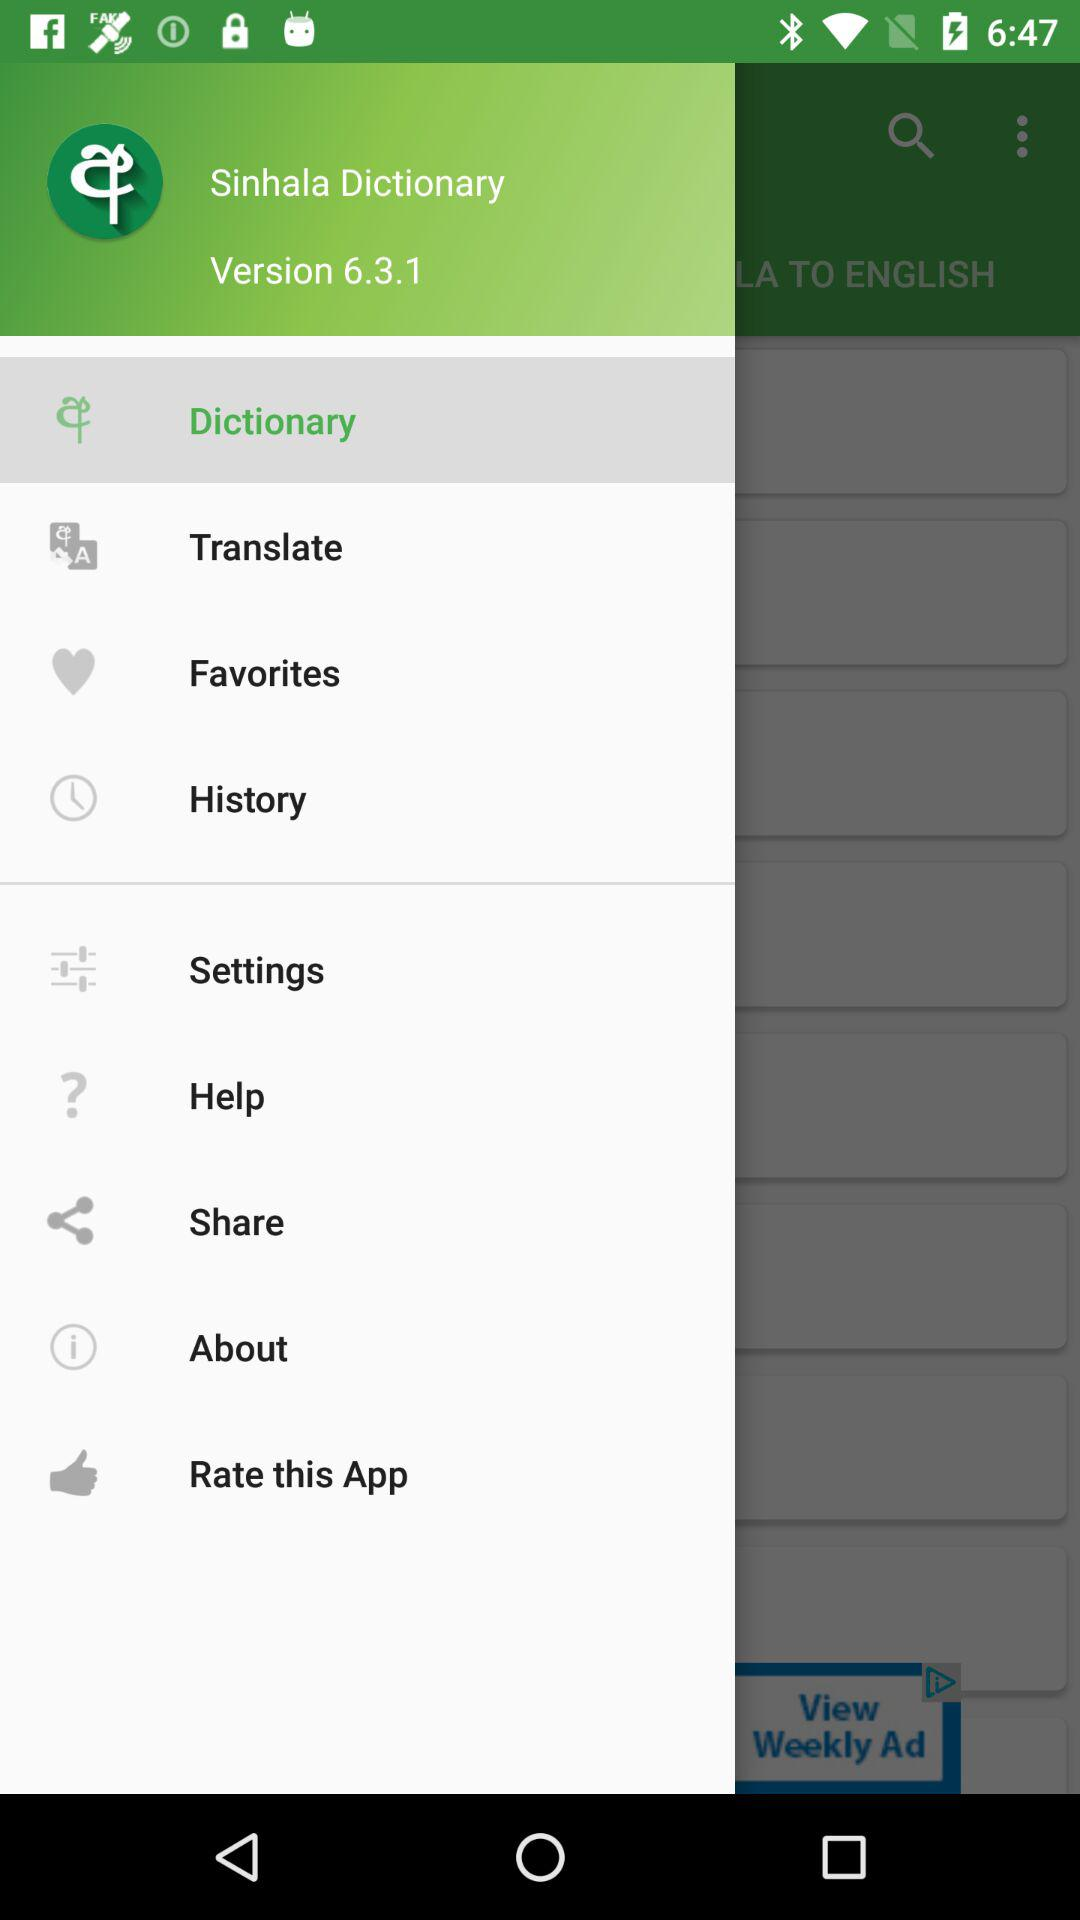What is the version? The version is 6.3.1. 